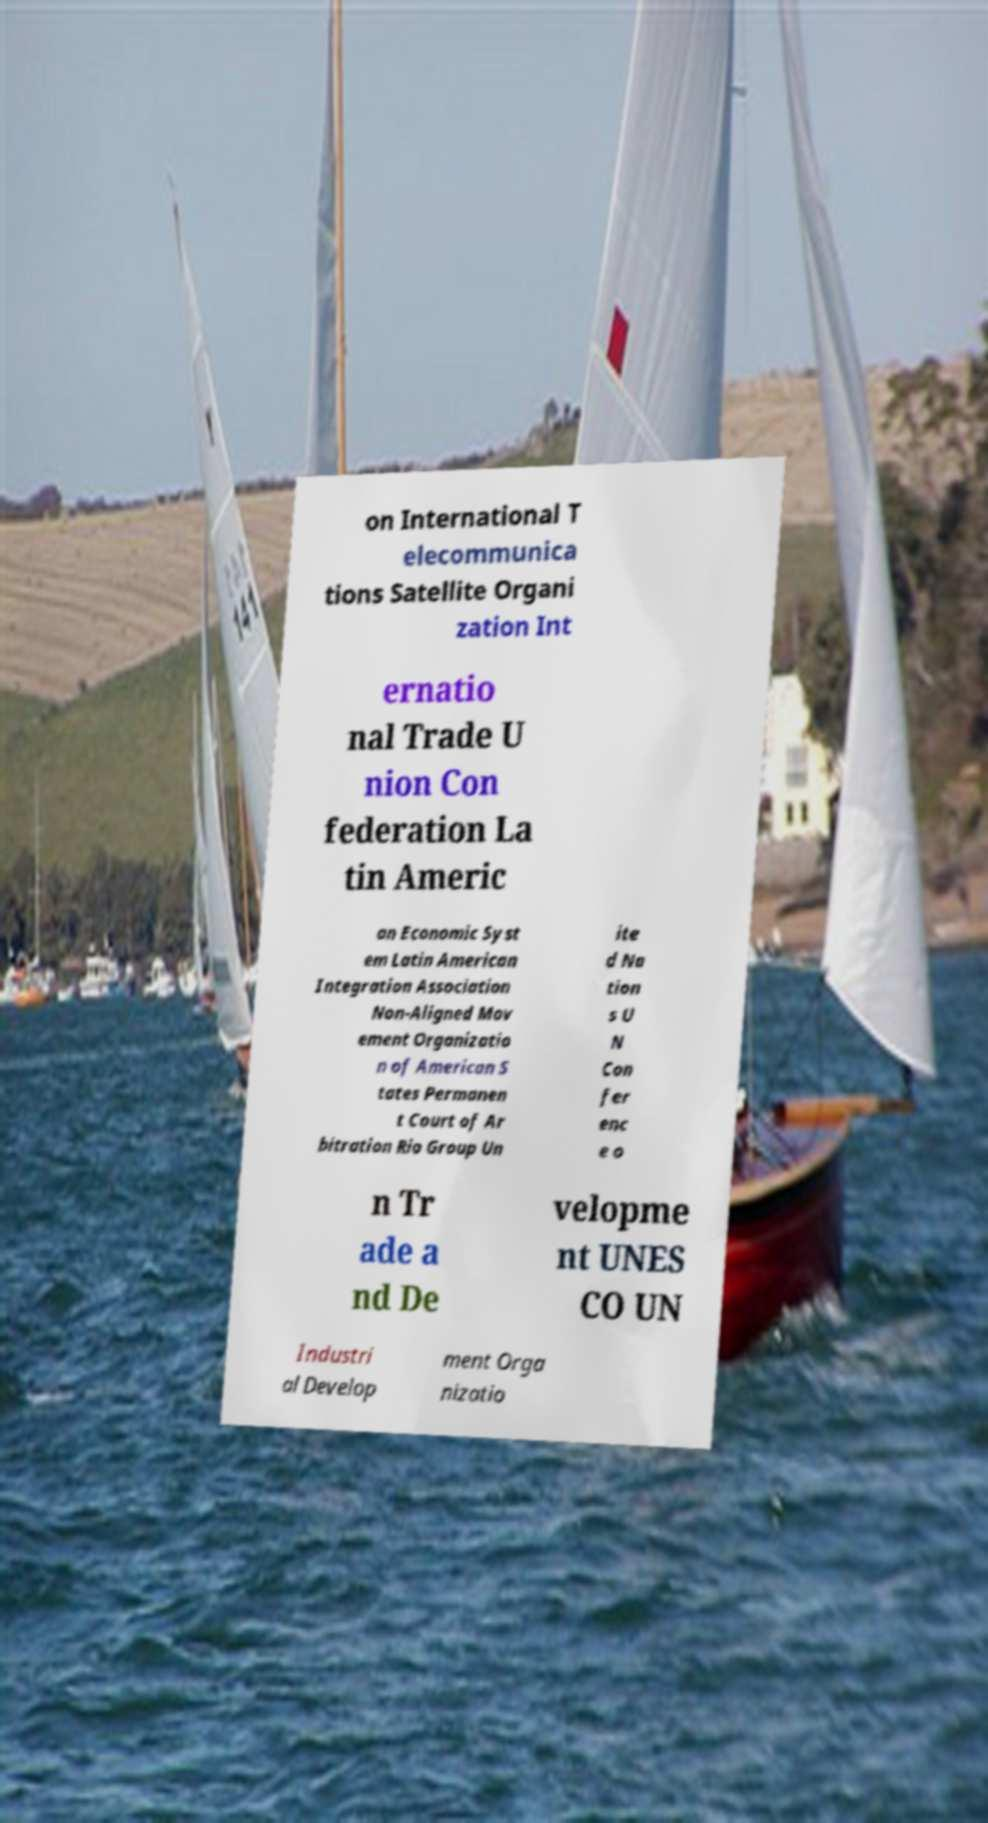Please read and relay the text visible in this image. What does it say? on International T elecommunica tions Satellite Organi zation Int ernatio nal Trade U nion Con federation La tin Americ an Economic Syst em Latin American Integration Association Non-Aligned Mov ement Organizatio n of American S tates Permanen t Court of Ar bitration Rio Group Un ite d Na tion s U N Con fer enc e o n Tr ade a nd De velopme nt UNES CO UN Industri al Develop ment Orga nizatio 